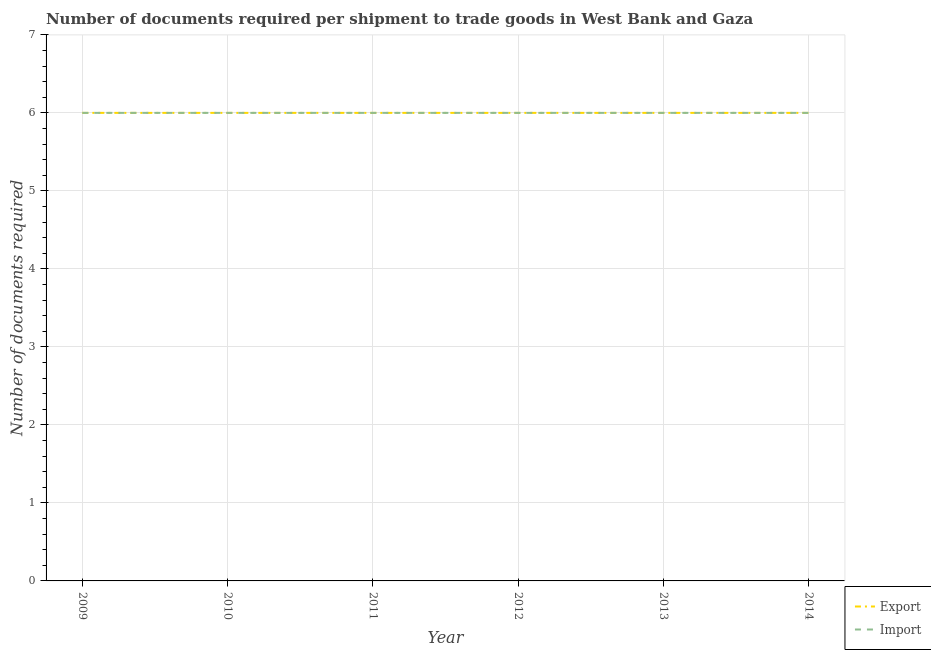How many different coloured lines are there?
Keep it short and to the point. 2. Does the line corresponding to number of documents required to import goods intersect with the line corresponding to number of documents required to export goods?
Give a very brief answer. Yes. Is the number of lines equal to the number of legend labels?
Ensure brevity in your answer.  Yes. What is the number of documents required to import goods in 2009?
Your response must be concise. 6. Across all years, what is the maximum number of documents required to export goods?
Your answer should be compact. 6. Across all years, what is the minimum number of documents required to import goods?
Your answer should be very brief. 6. In which year was the number of documents required to import goods maximum?
Keep it short and to the point. 2009. In which year was the number of documents required to import goods minimum?
Offer a very short reply. 2009. What is the total number of documents required to export goods in the graph?
Your response must be concise. 36. What is the difference between the number of documents required to export goods in 2011 and the number of documents required to import goods in 2009?
Provide a succinct answer. 0. What is the ratio of the number of documents required to export goods in 2012 to that in 2013?
Keep it short and to the point. 1. Is the number of documents required to export goods in 2010 less than that in 2013?
Your answer should be compact. No. What is the difference between the highest and the second highest number of documents required to export goods?
Ensure brevity in your answer.  0. Is the sum of the number of documents required to import goods in 2011 and 2013 greater than the maximum number of documents required to export goods across all years?
Your response must be concise. Yes. Are the values on the major ticks of Y-axis written in scientific E-notation?
Offer a terse response. No. Where does the legend appear in the graph?
Offer a terse response. Bottom right. How many legend labels are there?
Your answer should be compact. 2. How are the legend labels stacked?
Offer a very short reply. Vertical. What is the title of the graph?
Offer a very short reply. Number of documents required per shipment to trade goods in West Bank and Gaza. Does "Exports" appear as one of the legend labels in the graph?
Give a very brief answer. No. What is the label or title of the Y-axis?
Offer a terse response. Number of documents required. What is the Number of documents required in Import in 2009?
Ensure brevity in your answer.  6. What is the Number of documents required in Export in 2010?
Offer a terse response. 6. What is the Number of documents required in Import in 2010?
Provide a short and direct response. 6. What is the Number of documents required of Export in 2013?
Your answer should be compact. 6. What is the Number of documents required of Import in 2013?
Your answer should be very brief. 6. What is the Number of documents required of Export in 2014?
Ensure brevity in your answer.  6. What is the Number of documents required in Import in 2014?
Provide a short and direct response. 6. Across all years, what is the maximum Number of documents required in Import?
Provide a succinct answer. 6. Across all years, what is the minimum Number of documents required in Export?
Keep it short and to the point. 6. What is the total Number of documents required of Export in the graph?
Your answer should be very brief. 36. What is the difference between the Number of documents required in Export in 2009 and that in 2010?
Offer a very short reply. 0. What is the difference between the Number of documents required of Import in 2009 and that in 2010?
Your answer should be very brief. 0. What is the difference between the Number of documents required in Export in 2009 and that in 2011?
Your answer should be very brief. 0. What is the difference between the Number of documents required in Import in 2009 and that in 2011?
Make the answer very short. 0. What is the difference between the Number of documents required of Export in 2009 and that in 2012?
Provide a succinct answer. 0. What is the difference between the Number of documents required in Export in 2009 and that in 2013?
Give a very brief answer. 0. What is the difference between the Number of documents required in Import in 2009 and that in 2013?
Your response must be concise. 0. What is the difference between the Number of documents required in Import in 2009 and that in 2014?
Provide a short and direct response. 0. What is the difference between the Number of documents required in Import in 2010 and that in 2011?
Give a very brief answer. 0. What is the difference between the Number of documents required of Export in 2010 and that in 2012?
Make the answer very short. 0. What is the difference between the Number of documents required of Import in 2010 and that in 2012?
Offer a terse response. 0. What is the difference between the Number of documents required in Export in 2010 and that in 2014?
Offer a very short reply. 0. What is the difference between the Number of documents required in Import in 2010 and that in 2014?
Your response must be concise. 0. What is the difference between the Number of documents required of Export in 2011 and that in 2012?
Provide a succinct answer. 0. What is the difference between the Number of documents required in Import in 2011 and that in 2013?
Your response must be concise. 0. What is the difference between the Number of documents required of Import in 2011 and that in 2014?
Your answer should be compact. 0. What is the difference between the Number of documents required of Import in 2012 and that in 2013?
Make the answer very short. 0. What is the difference between the Number of documents required of Export in 2012 and that in 2014?
Your answer should be very brief. 0. What is the difference between the Number of documents required of Export in 2009 and the Number of documents required of Import in 2010?
Offer a terse response. 0. What is the difference between the Number of documents required in Export in 2009 and the Number of documents required in Import in 2013?
Your response must be concise. 0. What is the difference between the Number of documents required of Export in 2009 and the Number of documents required of Import in 2014?
Ensure brevity in your answer.  0. What is the difference between the Number of documents required in Export in 2010 and the Number of documents required in Import in 2011?
Offer a terse response. 0. What is the difference between the Number of documents required in Export in 2010 and the Number of documents required in Import in 2012?
Give a very brief answer. 0. What is the difference between the Number of documents required of Export in 2011 and the Number of documents required of Import in 2013?
Your answer should be very brief. 0. What is the difference between the Number of documents required in Export in 2013 and the Number of documents required in Import in 2014?
Provide a succinct answer. 0. What is the average Number of documents required in Import per year?
Offer a terse response. 6. In the year 2009, what is the difference between the Number of documents required of Export and Number of documents required of Import?
Your answer should be very brief. 0. In the year 2010, what is the difference between the Number of documents required in Export and Number of documents required in Import?
Your answer should be compact. 0. In the year 2012, what is the difference between the Number of documents required in Export and Number of documents required in Import?
Provide a succinct answer. 0. In the year 2014, what is the difference between the Number of documents required in Export and Number of documents required in Import?
Make the answer very short. 0. What is the ratio of the Number of documents required of Export in 2009 to that in 2010?
Offer a terse response. 1. What is the ratio of the Number of documents required of Export in 2009 to that in 2011?
Provide a succinct answer. 1. What is the ratio of the Number of documents required in Export in 2009 to that in 2012?
Make the answer very short. 1. What is the ratio of the Number of documents required of Export in 2009 to that in 2013?
Offer a very short reply. 1. What is the ratio of the Number of documents required of Import in 2009 to that in 2013?
Your answer should be compact. 1. What is the ratio of the Number of documents required in Export in 2009 to that in 2014?
Keep it short and to the point. 1. What is the ratio of the Number of documents required of Export in 2010 to that in 2013?
Your answer should be very brief. 1. What is the ratio of the Number of documents required of Import in 2010 to that in 2013?
Your answer should be compact. 1. What is the ratio of the Number of documents required in Export in 2010 to that in 2014?
Keep it short and to the point. 1. What is the ratio of the Number of documents required in Export in 2011 to that in 2013?
Offer a terse response. 1. What is the ratio of the Number of documents required in Import in 2011 to that in 2013?
Ensure brevity in your answer.  1. What is the ratio of the Number of documents required in Import in 2011 to that in 2014?
Your answer should be very brief. 1. What is the ratio of the Number of documents required of Export in 2012 to that in 2014?
Provide a succinct answer. 1. What is the ratio of the Number of documents required of Import in 2012 to that in 2014?
Give a very brief answer. 1. What is the ratio of the Number of documents required of Export in 2013 to that in 2014?
Ensure brevity in your answer.  1. What is the difference between the highest and the lowest Number of documents required of Import?
Offer a terse response. 0. 